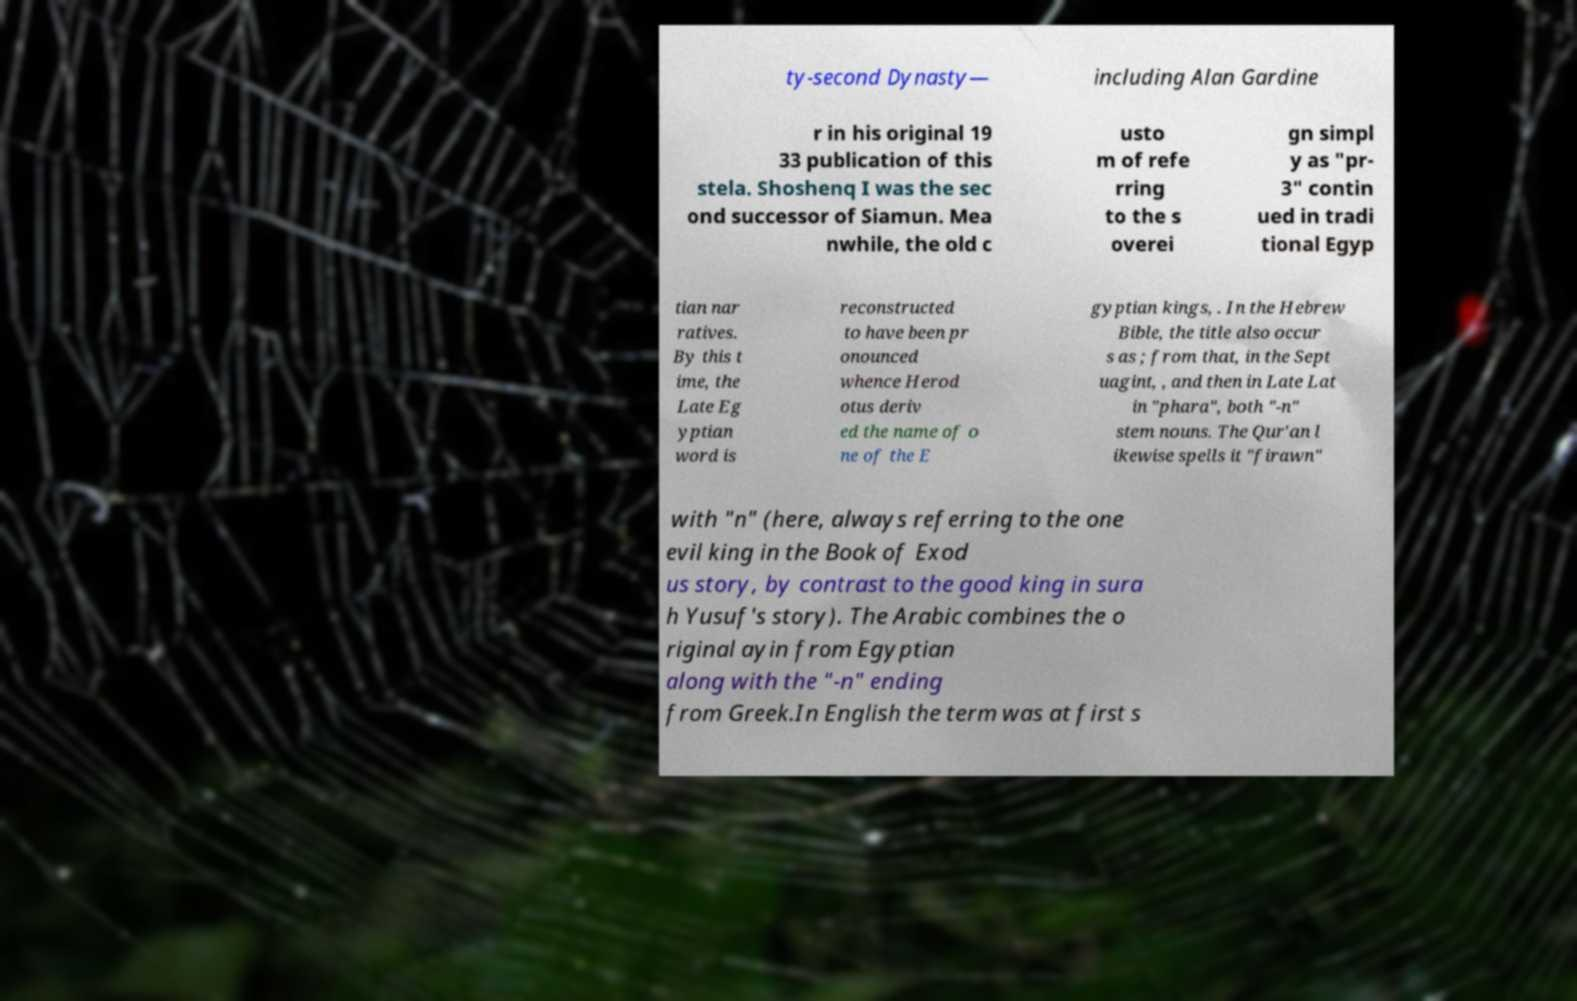Please identify and transcribe the text found in this image. ty-second Dynasty— including Alan Gardine r in his original 19 33 publication of this stela. Shoshenq I was the sec ond successor of Siamun. Mea nwhile, the old c usto m of refe rring to the s overei gn simpl y as "pr- 3" contin ued in tradi tional Egyp tian nar ratives. By this t ime, the Late Eg yptian word is reconstructed to have been pr onounced whence Herod otus deriv ed the name of o ne of the E gyptian kings, . In the Hebrew Bible, the title also occur s as ; from that, in the Sept uagint, , and then in Late Lat in "phara", both "-n" stem nouns. The Qur'an l ikewise spells it "firawn" with "n" (here, always referring to the one evil king in the Book of Exod us story, by contrast to the good king in sura h Yusuf's story). The Arabic combines the o riginal ayin from Egyptian along with the "-n" ending from Greek.In English the term was at first s 